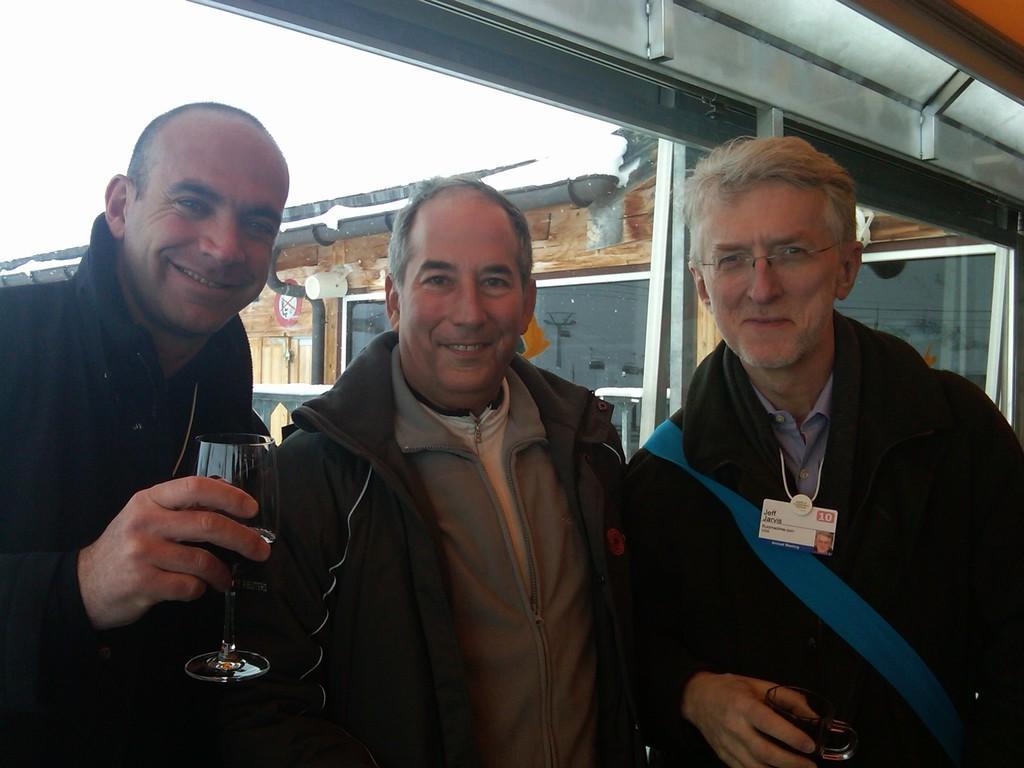Could you give a brief overview of what you see in this image? In this picture I can see three men are smiling and wearing the coats, in the background there is a house. 